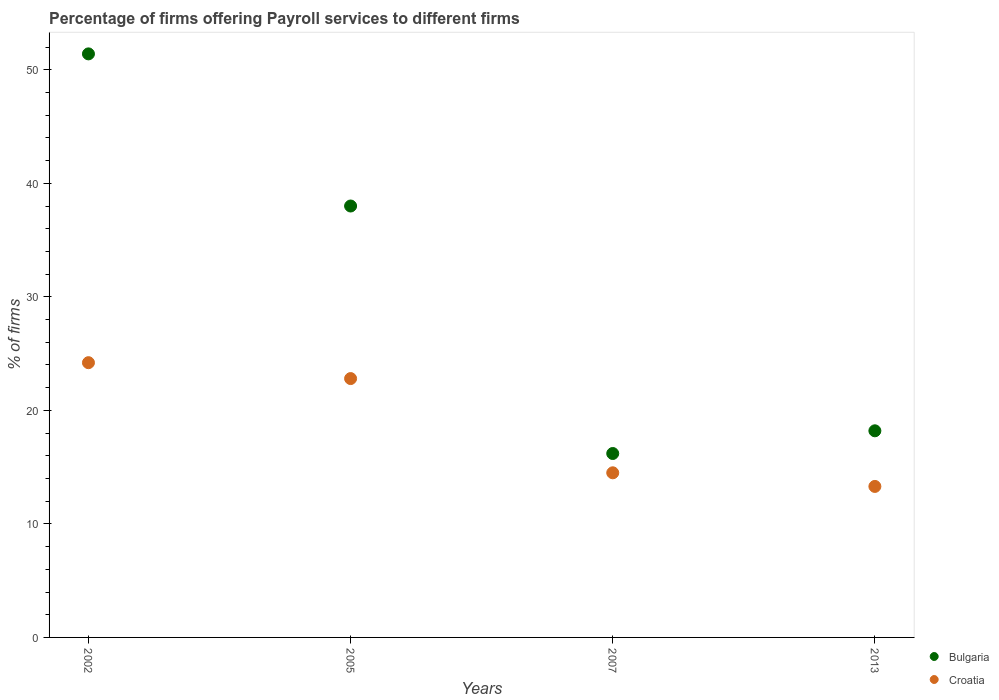Is the number of dotlines equal to the number of legend labels?
Provide a succinct answer. Yes. What is the percentage of firms offering payroll services in Croatia in 2007?
Offer a very short reply. 14.5. Across all years, what is the maximum percentage of firms offering payroll services in Bulgaria?
Ensure brevity in your answer.  51.4. What is the total percentage of firms offering payroll services in Bulgaria in the graph?
Your answer should be compact. 123.8. What is the difference between the percentage of firms offering payroll services in Bulgaria in 2002 and that in 2007?
Offer a very short reply. 35.2. What is the average percentage of firms offering payroll services in Bulgaria per year?
Ensure brevity in your answer.  30.95. In the year 2002, what is the difference between the percentage of firms offering payroll services in Bulgaria and percentage of firms offering payroll services in Croatia?
Provide a succinct answer. 27.2. In how many years, is the percentage of firms offering payroll services in Bulgaria greater than 24 %?
Offer a terse response. 2. What is the ratio of the percentage of firms offering payroll services in Croatia in 2005 to that in 2007?
Make the answer very short. 1.57. Is the percentage of firms offering payroll services in Croatia in 2002 less than that in 2007?
Offer a terse response. No. What is the difference between the highest and the second highest percentage of firms offering payroll services in Croatia?
Offer a terse response. 1.4. What is the difference between the highest and the lowest percentage of firms offering payroll services in Bulgaria?
Ensure brevity in your answer.  35.2. Is the sum of the percentage of firms offering payroll services in Croatia in 2007 and 2013 greater than the maximum percentage of firms offering payroll services in Bulgaria across all years?
Provide a short and direct response. No. Is the percentage of firms offering payroll services in Croatia strictly greater than the percentage of firms offering payroll services in Bulgaria over the years?
Make the answer very short. No. How many dotlines are there?
Your answer should be compact. 2. How many years are there in the graph?
Provide a short and direct response. 4. Does the graph contain grids?
Your response must be concise. No. How many legend labels are there?
Offer a terse response. 2. What is the title of the graph?
Ensure brevity in your answer.  Percentage of firms offering Payroll services to different firms. What is the label or title of the X-axis?
Offer a very short reply. Years. What is the label or title of the Y-axis?
Give a very brief answer. % of firms. What is the % of firms of Bulgaria in 2002?
Offer a very short reply. 51.4. What is the % of firms of Croatia in 2002?
Your answer should be compact. 24.2. What is the % of firms in Croatia in 2005?
Offer a very short reply. 22.8. What is the % of firms in Bulgaria in 2007?
Your answer should be very brief. 16.2. What is the % of firms in Bulgaria in 2013?
Make the answer very short. 18.2. What is the % of firms in Croatia in 2013?
Your answer should be very brief. 13.3. Across all years, what is the maximum % of firms of Bulgaria?
Give a very brief answer. 51.4. Across all years, what is the maximum % of firms of Croatia?
Give a very brief answer. 24.2. What is the total % of firms of Bulgaria in the graph?
Make the answer very short. 123.8. What is the total % of firms in Croatia in the graph?
Your answer should be compact. 74.8. What is the difference between the % of firms in Bulgaria in 2002 and that in 2005?
Provide a short and direct response. 13.4. What is the difference between the % of firms of Bulgaria in 2002 and that in 2007?
Make the answer very short. 35.2. What is the difference between the % of firms of Bulgaria in 2002 and that in 2013?
Your response must be concise. 33.2. What is the difference between the % of firms in Croatia in 2002 and that in 2013?
Give a very brief answer. 10.9. What is the difference between the % of firms of Bulgaria in 2005 and that in 2007?
Give a very brief answer. 21.8. What is the difference between the % of firms of Croatia in 2005 and that in 2007?
Provide a short and direct response. 8.3. What is the difference between the % of firms in Bulgaria in 2005 and that in 2013?
Make the answer very short. 19.8. What is the difference between the % of firms in Croatia in 2005 and that in 2013?
Keep it short and to the point. 9.5. What is the difference between the % of firms in Bulgaria in 2007 and that in 2013?
Offer a terse response. -2. What is the difference between the % of firms in Croatia in 2007 and that in 2013?
Provide a succinct answer. 1.2. What is the difference between the % of firms in Bulgaria in 2002 and the % of firms in Croatia in 2005?
Keep it short and to the point. 28.6. What is the difference between the % of firms of Bulgaria in 2002 and the % of firms of Croatia in 2007?
Your answer should be compact. 36.9. What is the difference between the % of firms in Bulgaria in 2002 and the % of firms in Croatia in 2013?
Offer a terse response. 38.1. What is the difference between the % of firms of Bulgaria in 2005 and the % of firms of Croatia in 2013?
Offer a very short reply. 24.7. What is the average % of firms in Bulgaria per year?
Your answer should be very brief. 30.95. In the year 2002, what is the difference between the % of firms of Bulgaria and % of firms of Croatia?
Your answer should be compact. 27.2. What is the ratio of the % of firms in Bulgaria in 2002 to that in 2005?
Keep it short and to the point. 1.35. What is the ratio of the % of firms in Croatia in 2002 to that in 2005?
Your answer should be compact. 1.06. What is the ratio of the % of firms in Bulgaria in 2002 to that in 2007?
Make the answer very short. 3.17. What is the ratio of the % of firms in Croatia in 2002 to that in 2007?
Offer a terse response. 1.67. What is the ratio of the % of firms of Bulgaria in 2002 to that in 2013?
Ensure brevity in your answer.  2.82. What is the ratio of the % of firms of Croatia in 2002 to that in 2013?
Provide a succinct answer. 1.82. What is the ratio of the % of firms in Bulgaria in 2005 to that in 2007?
Provide a short and direct response. 2.35. What is the ratio of the % of firms of Croatia in 2005 to that in 2007?
Offer a very short reply. 1.57. What is the ratio of the % of firms of Bulgaria in 2005 to that in 2013?
Give a very brief answer. 2.09. What is the ratio of the % of firms of Croatia in 2005 to that in 2013?
Give a very brief answer. 1.71. What is the ratio of the % of firms of Bulgaria in 2007 to that in 2013?
Your response must be concise. 0.89. What is the ratio of the % of firms of Croatia in 2007 to that in 2013?
Give a very brief answer. 1.09. What is the difference between the highest and the second highest % of firms in Croatia?
Provide a succinct answer. 1.4. What is the difference between the highest and the lowest % of firms in Bulgaria?
Your answer should be very brief. 35.2. What is the difference between the highest and the lowest % of firms of Croatia?
Offer a terse response. 10.9. 